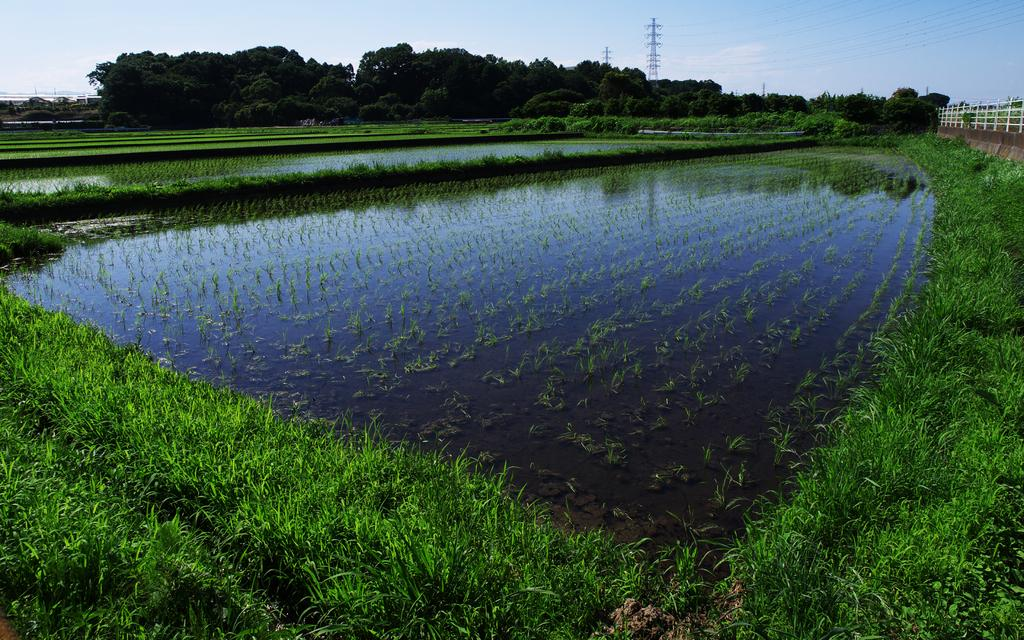What type of landscape is depicted in the image? The image features farmland. What natural element can be seen in the image? Water is visible in the image. What type of vegetation is present in the image? There are trees in the image. What man-made structure is present in the image? There is a fence in the image. What tall structures can be seen in the image? There are towers in the image. What is visible in the background of the image? The sky is visible in the background of the image. What type of leather is being mined in the image? There is no leather or mining activity present in the image. What type of powder is visible on the ground in the image? There is no powder visible on the ground in the image. 